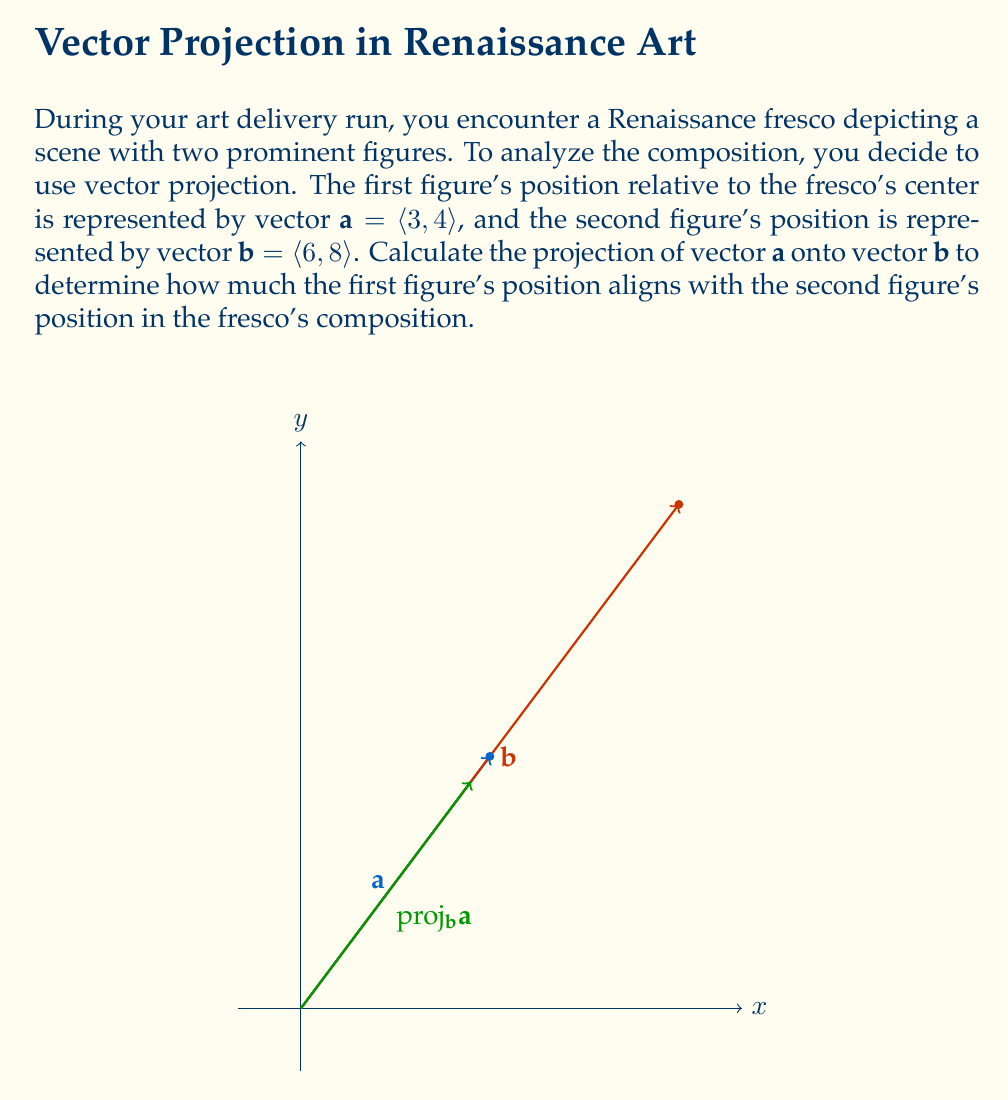Could you help me with this problem? To calculate the projection of vector $\mathbf{a}$ onto vector $\mathbf{b}$, we'll use the formula:

$$\text{proj}_\mathbf{b}\mathbf{a} = \frac{\mathbf{a} \cdot \mathbf{b}}{\|\mathbf{b}\|^2} \mathbf{b}$$

Let's break this down step-by-step:

1) First, calculate the dot product $\mathbf{a} \cdot \mathbf{b}$:
   $\mathbf{a} \cdot \mathbf{b} = (3 \times 6) + (4 \times 8) = 18 + 32 = 50$

2) Next, calculate $\|\mathbf{b}\|^2$ (the magnitude of $\mathbf{b}$ squared):
   $\|\mathbf{b}\|^2 = 6^2 + 8^2 = 36 + 64 = 100$

3) Now, calculate the scalar projection:
   $\frac{\mathbf{a} \cdot \mathbf{b}}{\|\mathbf{b}\|^2} = \frac{50}{100} = 0.5$

4) Finally, multiply this scalar by vector $\mathbf{b}$ to get the vector projection:
   $\text{proj}_\mathbf{b}\mathbf{a} = 0.5 \mathbf{b} = 0.5 \langle 6, 8 \rangle = \langle 3, 4 \rangle$

Thus, the projection of $\mathbf{a}$ onto $\mathbf{b}$ is $\langle 3, 4 \rangle$.
Answer: $\langle 3, 4 \rangle$ 